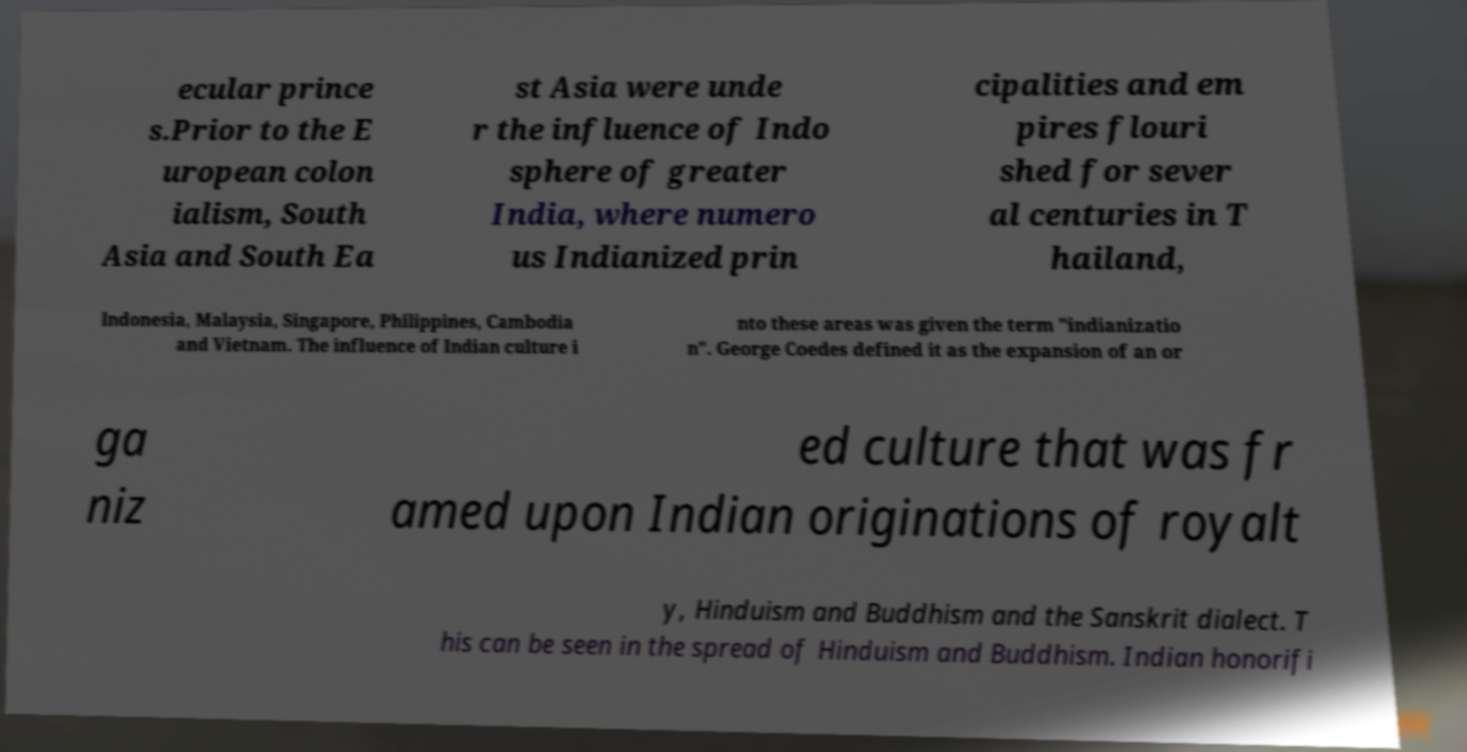There's text embedded in this image that I need extracted. Can you transcribe it verbatim? ecular prince s.Prior to the E uropean colon ialism, South Asia and South Ea st Asia were unde r the influence of Indo sphere of greater India, where numero us Indianized prin cipalities and em pires flouri shed for sever al centuries in T hailand, Indonesia, Malaysia, Singapore, Philippines, Cambodia and Vietnam. The influence of Indian culture i nto these areas was given the term "indianizatio n". George Coedes defined it as the expansion of an or ga niz ed culture that was fr amed upon Indian originations of royalt y, Hinduism and Buddhism and the Sanskrit dialect. T his can be seen in the spread of Hinduism and Buddhism. Indian honorifi 